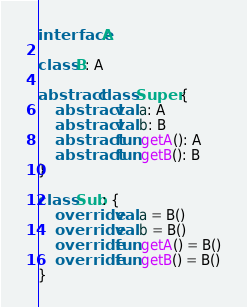Convert code to text. <code><loc_0><loc_0><loc_500><loc_500><_Kotlin_>interface A

class B: A

abstract class Super {
    abstract val a: A
    abstract val b: B
    abstract fun getA(): A
    abstract fun getB(): B
}

class Sub: {
    override val a = B()
    override val b = B()
    override fun getA() = B()
    override fun getB() = B()
}</code> 